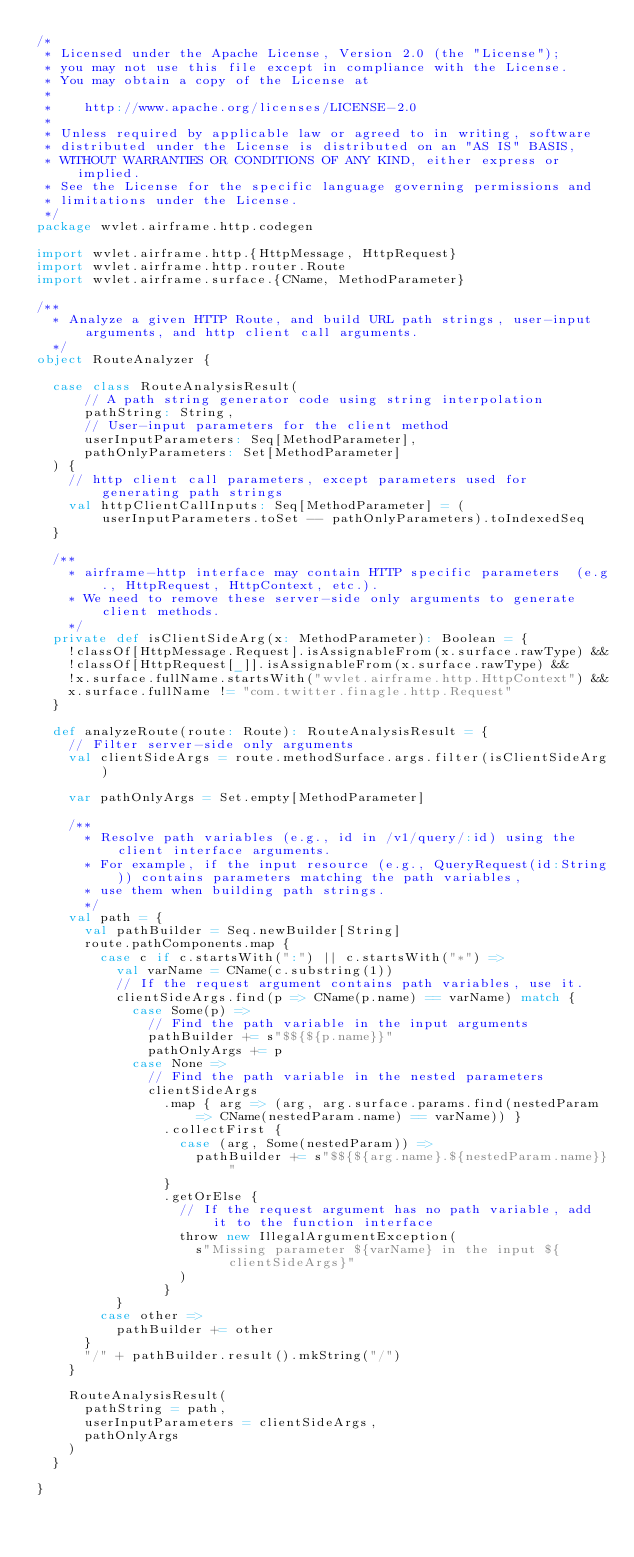Convert code to text. <code><loc_0><loc_0><loc_500><loc_500><_Scala_>/*
 * Licensed under the Apache License, Version 2.0 (the "License");
 * you may not use this file except in compliance with the License.
 * You may obtain a copy of the License at
 *
 *    http://www.apache.org/licenses/LICENSE-2.0
 *
 * Unless required by applicable law or agreed to in writing, software
 * distributed under the License is distributed on an "AS IS" BASIS,
 * WITHOUT WARRANTIES OR CONDITIONS OF ANY KIND, either express or implied.
 * See the License for the specific language governing permissions and
 * limitations under the License.
 */
package wvlet.airframe.http.codegen

import wvlet.airframe.http.{HttpMessage, HttpRequest}
import wvlet.airframe.http.router.Route
import wvlet.airframe.surface.{CName, MethodParameter}

/**
  * Analyze a given HTTP Route, and build URL path strings, user-input arguments, and http client call arguments.
  */
object RouteAnalyzer {

  case class RouteAnalysisResult(
      // A path string generator code using string interpolation
      pathString: String,
      // User-input parameters for the client method
      userInputParameters: Seq[MethodParameter],
      pathOnlyParameters: Set[MethodParameter]
  ) {
    // http client call parameters, except parameters used for generating path strings
    val httpClientCallInputs: Seq[MethodParameter] = (userInputParameters.toSet -- pathOnlyParameters).toIndexedSeq
  }

  /**
    * airframe-http interface may contain HTTP specific parameters  (e.g., HttpRequest, HttpContext, etc.).
    * We need to remove these server-side only arguments to generate client methods.
    */
  private def isClientSideArg(x: MethodParameter): Boolean = {
    !classOf[HttpMessage.Request].isAssignableFrom(x.surface.rawType) &&
    !classOf[HttpRequest[_]].isAssignableFrom(x.surface.rawType) &&
    !x.surface.fullName.startsWith("wvlet.airframe.http.HttpContext") &&
    x.surface.fullName != "com.twitter.finagle.http.Request"
  }

  def analyzeRoute(route: Route): RouteAnalysisResult = {
    // Filter server-side only arguments
    val clientSideArgs = route.methodSurface.args.filter(isClientSideArg)

    var pathOnlyArgs = Set.empty[MethodParameter]

    /**
      * Resolve path variables (e.g., id in /v1/query/:id) using the client interface arguments.
      * For example, if the input resource (e.g., QueryRequest(id:String)) contains parameters matching the path variables,
      * use them when building path strings.
      */
    val path = {
      val pathBuilder = Seq.newBuilder[String]
      route.pathComponents.map {
        case c if c.startsWith(":") || c.startsWith("*") =>
          val varName = CName(c.substring(1))
          // If the request argument contains path variables, use it.
          clientSideArgs.find(p => CName(p.name) == varName) match {
            case Some(p) =>
              // Find the path variable in the input arguments
              pathBuilder += s"$${${p.name}}"
              pathOnlyArgs += p
            case None =>
              // Find the path variable in the nested parameters
              clientSideArgs
                .map { arg => (arg, arg.surface.params.find(nestedParam => CName(nestedParam.name) == varName)) }
                .collectFirst {
                  case (arg, Some(nestedParam)) =>
                    pathBuilder += s"$${${arg.name}.${nestedParam.name}}"
                }
                .getOrElse {
                  // If the request argument has no path variable, add it to the function interface
                  throw new IllegalArgumentException(
                    s"Missing parameter ${varName} in the input ${clientSideArgs}"
                  )
                }
          }
        case other =>
          pathBuilder += other
      }
      "/" + pathBuilder.result().mkString("/")
    }

    RouteAnalysisResult(
      pathString = path,
      userInputParameters = clientSideArgs,
      pathOnlyArgs
    )
  }

}
</code> 